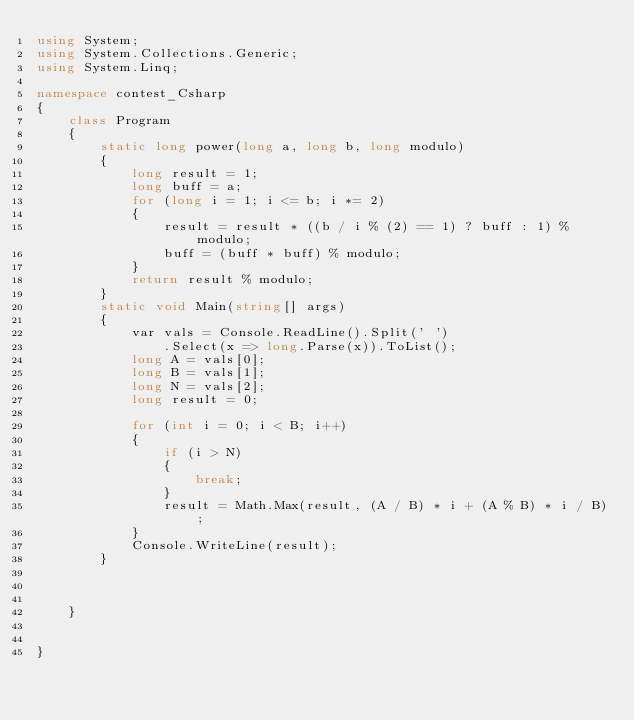Convert code to text. <code><loc_0><loc_0><loc_500><loc_500><_C#_>using System;
using System.Collections.Generic;
using System.Linq;

namespace contest_Csharp
{
    class Program
    {
        static long power(long a, long b, long modulo)
        {
            long result = 1;
            long buff = a;
            for (long i = 1; i <= b; i *= 2)
            {
                result = result * ((b / i % (2) == 1) ? buff : 1) % modulo;
                buff = (buff * buff) % modulo;
            }
            return result % modulo;
        }
        static void Main(string[] args)
        {
            var vals = Console.ReadLine().Split(' ')
                .Select(x => long.Parse(x)).ToList();
            long A = vals[0];
            long B = vals[1];
            long N = vals[2];
            long result = 0;

            for (int i = 0; i < B; i++)
            {
                if (i > N)
                {
                    break;
                }
                result = Math.Max(result, (A / B) * i + (A % B) * i / B);
            }
            Console.WriteLine(result);
        }



    }


}
</code> 